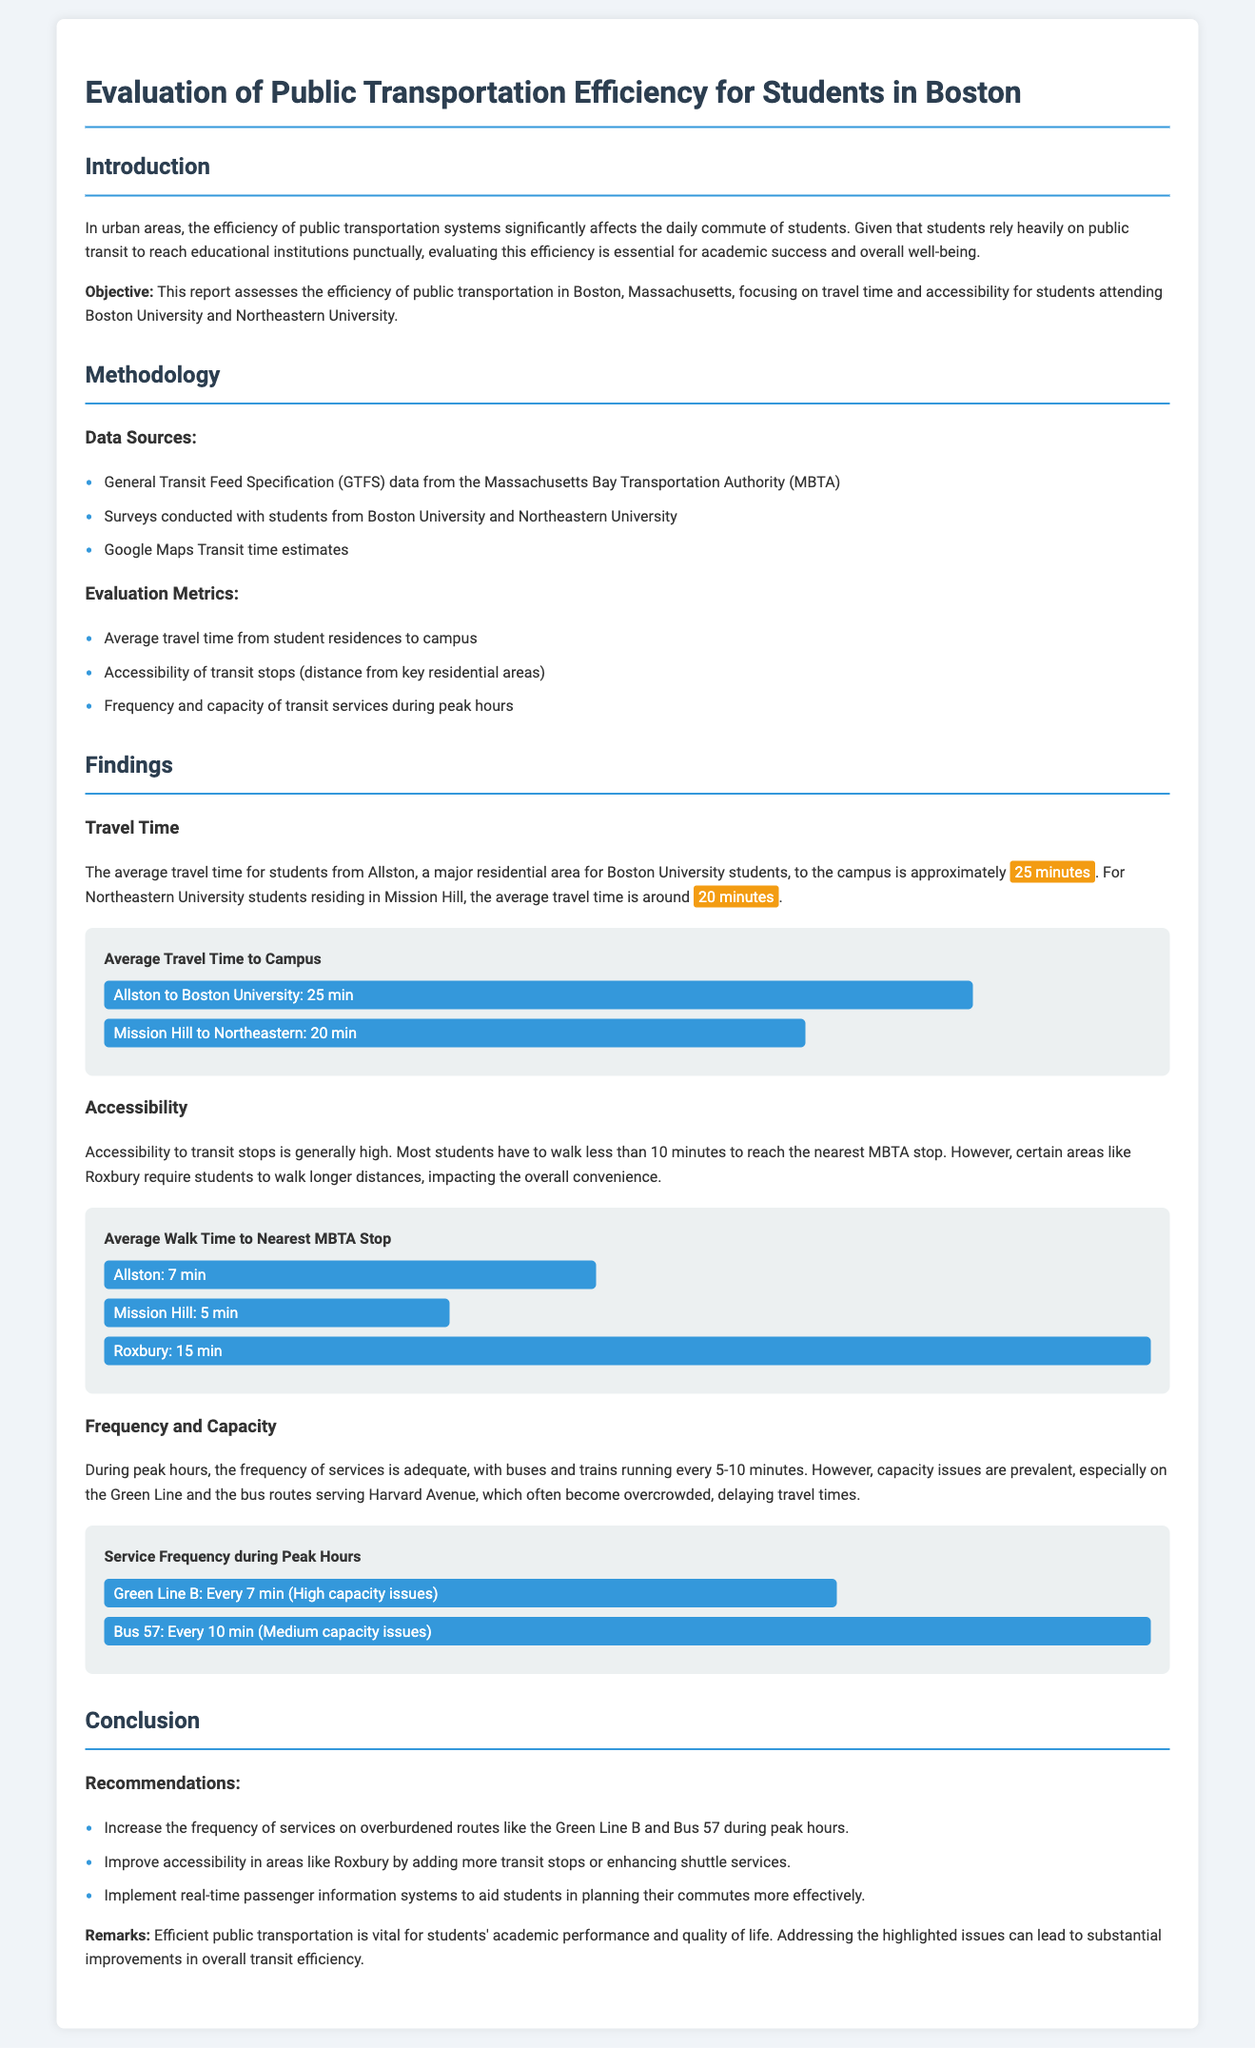What is the average travel time from Allston to Boston University? The average travel time stated in the report is approximately 25 minutes.
Answer: 25 minutes What is the average walk time to the nearest MBTA stop in Roxbury? The report indicates that the average walk time to the nearest MBTA stop in Roxbury is 15 minutes.
Answer: 15 minutes Which route experiences high capacity issues during peak hours? The report specifically mentions "Green Line B" as a route that has high capacity issues.
Answer: Green Line B What percentage of students from Allston walk less than 10 minutes to the nearest transit stop? The report does not provide a specific percentage but states that most students have to walk less than 10 minutes.
Answer: Most students What does the report recommend for improving accessibility in Roxbury? The report recommends adding more transit stops or enhancing shuttle services in Roxbury.
Answer: More transit stops or enhancing shuttle services How often do buses and trains run during peak hours according to the report? The report states that buses and trains run every 5-10 minutes during peak hours.
Answer: Every 5-10 minutes What is the average travel time for students from Mission Hill to Northeastern University? The average travel time from Mission Hill to Northeastern is reported to be around 20 minutes.
Answer: 20 minutes What type of data was used for the study? The methodology highlights three types of data sources: GTFS data, surveys, and Google Maps Transit time estimates.
Answer: GTFS data, surveys, and Google Maps Transit time estimates What is the objective of the report? The objective is to assess the efficiency of public transportation in Boston for students based on travel time and accessibility data.
Answer: Assess the efficiency of public transportation for students 